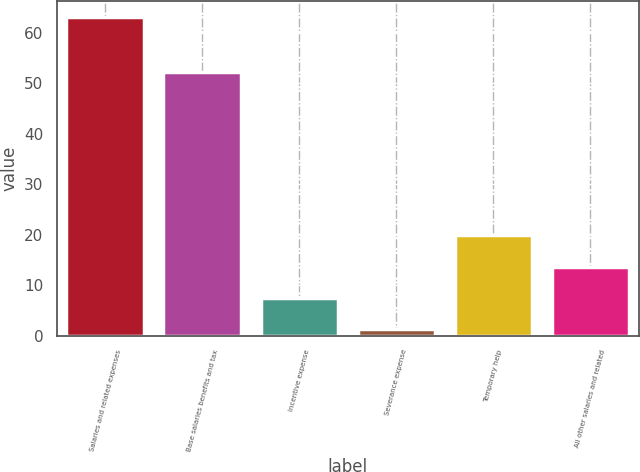Convert chart. <chart><loc_0><loc_0><loc_500><loc_500><bar_chart><fcel>Salaries and related expenses<fcel>Base salaries benefits and tax<fcel>Incentive expense<fcel>Severance expense<fcel>Temporary help<fcel>All other salaries and related<nl><fcel>63.1<fcel>52.2<fcel>7.48<fcel>1.3<fcel>19.84<fcel>13.66<nl></chart> 